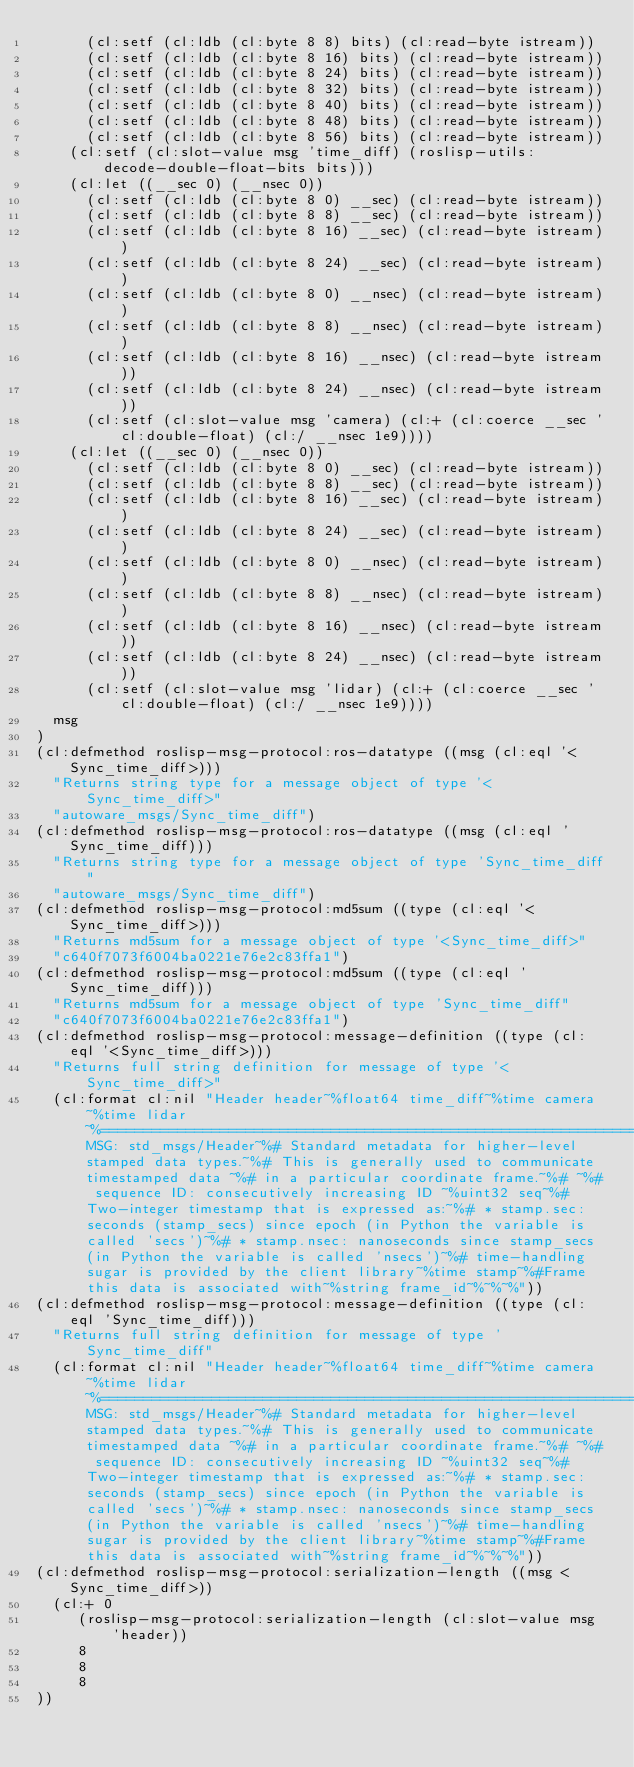<code> <loc_0><loc_0><loc_500><loc_500><_Lisp_>      (cl:setf (cl:ldb (cl:byte 8 8) bits) (cl:read-byte istream))
      (cl:setf (cl:ldb (cl:byte 8 16) bits) (cl:read-byte istream))
      (cl:setf (cl:ldb (cl:byte 8 24) bits) (cl:read-byte istream))
      (cl:setf (cl:ldb (cl:byte 8 32) bits) (cl:read-byte istream))
      (cl:setf (cl:ldb (cl:byte 8 40) bits) (cl:read-byte istream))
      (cl:setf (cl:ldb (cl:byte 8 48) bits) (cl:read-byte istream))
      (cl:setf (cl:ldb (cl:byte 8 56) bits) (cl:read-byte istream))
    (cl:setf (cl:slot-value msg 'time_diff) (roslisp-utils:decode-double-float-bits bits)))
    (cl:let ((__sec 0) (__nsec 0))
      (cl:setf (cl:ldb (cl:byte 8 0) __sec) (cl:read-byte istream))
      (cl:setf (cl:ldb (cl:byte 8 8) __sec) (cl:read-byte istream))
      (cl:setf (cl:ldb (cl:byte 8 16) __sec) (cl:read-byte istream))
      (cl:setf (cl:ldb (cl:byte 8 24) __sec) (cl:read-byte istream))
      (cl:setf (cl:ldb (cl:byte 8 0) __nsec) (cl:read-byte istream))
      (cl:setf (cl:ldb (cl:byte 8 8) __nsec) (cl:read-byte istream))
      (cl:setf (cl:ldb (cl:byte 8 16) __nsec) (cl:read-byte istream))
      (cl:setf (cl:ldb (cl:byte 8 24) __nsec) (cl:read-byte istream))
      (cl:setf (cl:slot-value msg 'camera) (cl:+ (cl:coerce __sec 'cl:double-float) (cl:/ __nsec 1e9))))
    (cl:let ((__sec 0) (__nsec 0))
      (cl:setf (cl:ldb (cl:byte 8 0) __sec) (cl:read-byte istream))
      (cl:setf (cl:ldb (cl:byte 8 8) __sec) (cl:read-byte istream))
      (cl:setf (cl:ldb (cl:byte 8 16) __sec) (cl:read-byte istream))
      (cl:setf (cl:ldb (cl:byte 8 24) __sec) (cl:read-byte istream))
      (cl:setf (cl:ldb (cl:byte 8 0) __nsec) (cl:read-byte istream))
      (cl:setf (cl:ldb (cl:byte 8 8) __nsec) (cl:read-byte istream))
      (cl:setf (cl:ldb (cl:byte 8 16) __nsec) (cl:read-byte istream))
      (cl:setf (cl:ldb (cl:byte 8 24) __nsec) (cl:read-byte istream))
      (cl:setf (cl:slot-value msg 'lidar) (cl:+ (cl:coerce __sec 'cl:double-float) (cl:/ __nsec 1e9))))
  msg
)
(cl:defmethod roslisp-msg-protocol:ros-datatype ((msg (cl:eql '<Sync_time_diff>)))
  "Returns string type for a message object of type '<Sync_time_diff>"
  "autoware_msgs/Sync_time_diff")
(cl:defmethod roslisp-msg-protocol:ros-datatype ((msg (cl:eql 'Sync_time_diff)))
  "Returns string type for a message object of type 'Sync_time_diff"
  "autoware_msgs/Sync_time_diff")
(cl:defmethod roslisp-msg-protocol:md5sum ((type (cl:eql '<Sync_time_diff>)))
  "Returns md5sum for a message object of type '<Sync_time_diff>"
  "c640f7073f6004ba0221e76e2c83ffa1")
(cl:defmethod roslisp-msg-protocol:md5sum ((type (cl:eql 'Sync_time_diff)))
  "Returns md5sum for a message object of type 'Sync_time_diff"
  "c640f7073f6004ba0221e76e2c83ffa1")
(cl:defmethod roslisp-msg-protocol:message-definition ((type (cl:eql '<Sync_time_diff>)))
  "Returns full string definition for message of type '<Sync_time_diff>"
  (cl:format cl:nil "Header header~%float64 time_diff~%time camera~%time lidar~%================================================================================~%MSG: std_msgs/Header~%# Standard metadata for higher-level stamped data types.~%# This is generally used to communicate timestamped data ~%# in a particular coordinate frame.~%# ~%# sequence ID: consecutively increasing ID ~%uint32 seq~%#Two-integer timestamp that is expressed as:~%# * stamp.sec: seconds (stamp_secs) since epoch (in Python the variable is called 'secs')~%# * stamp.nsec: nanoseconds since stamp_secs (in Python the variable is called 'nsecs')~%# time-handling sugar is provided by the client library~%time stamp~%#Frame this data is associated with~%string frame_id~%~%~%"))
(cl:defmethod roslisp-msg-protocol:message-definition ((type (cl:eql 'Sync_time_diff)))
  "Returns full string definition for message of type 'Sync_time_diff"
  (cl:format cl:nil "Header header~%float64 time_diff~%time camera~%time lidar~%================================================================================~%MSG: std_msgs/Header~%# Standard metadata for higher-level stamped data types.~%# This is generally used to communicate timestamped data ~%# in a particular coordinate frame.~%# ~%# sequence ID: consecutively increasing ID ~%uint32 seq~%#Two-integer timestamp that is expressed as:~%# * stamp.sec: seconds (stamp_secs) since epoch (in Python the variable is called 'secs')~%# * stamp.nsec: nanoseconds since stamp_secs (in Python the variable is called 'nsecs')~%# time-handling sugar is provided by the client library~%time stamp~%#Frame this data is associated with~%string frame_id~%~%~%"))
(cl:defmethod roslisp-msg-protocol:serialization-length ((msg <Sync_time_diff>))
  (cl:+ 0
     (roslisp-msg-protocol:serialization-length (cl:slot-value msg 'header))
     8
     8
     8
))</code> 